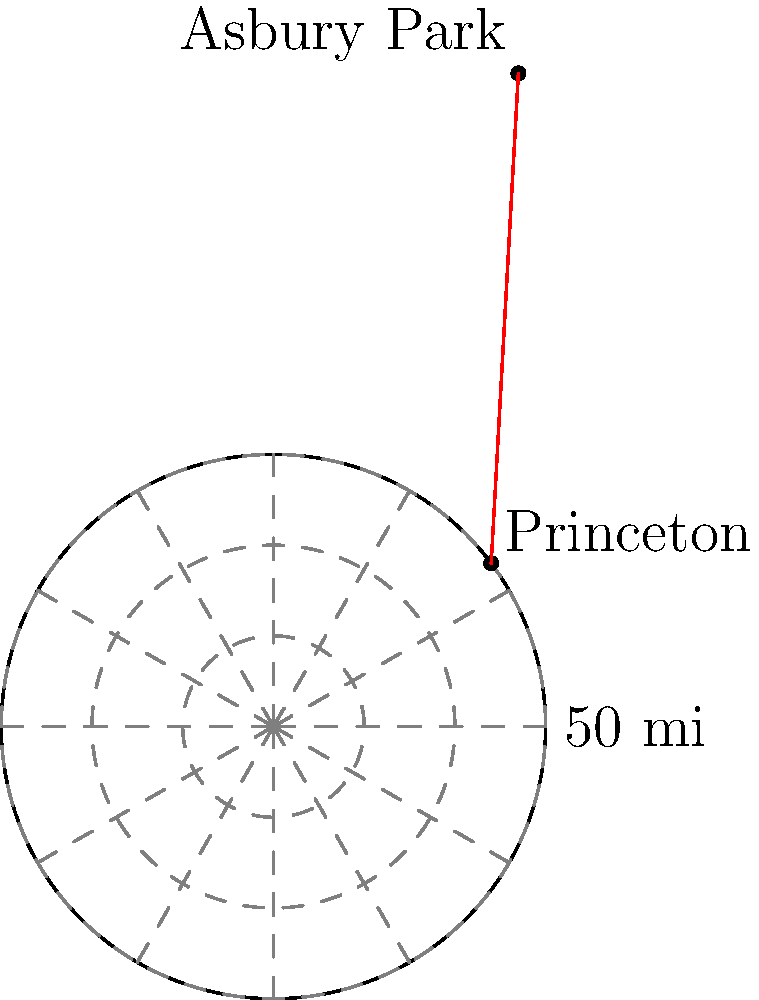As a proud member of the Central Jersey Club, you're planning a trip from Princeton to Asbury Park. On your polar coordinate map of New Jersey (with Princeton at the origin), Princeton is located at $(40, 30°)$ and Asbury Park is at $(45, 120°)$. Calculate the straight-line distance between these two landmarks in miles. To find the distance between two points in polar coordinates, we can use the polar form of the distance formula:

$$d = \sqrt{r_1^2 + r_2^2 - 2r_1r_2\cos(\theta_2 - \theta_1)}$$

Where:
- $r_1 = 40$ miles (Princeton's radius)
- $r_2 = 45$ miles (Asbury Park's radius)
- $\theta_1 = 30°$ (Princeton's angle)
- $\theta_2 = 120°$ (Asbury Park's angle)

Let's solve step by step:

1) First, calculate $\theta_2 - \theta_1$:
   $120° - 30° = 90°$

2) Now, let's plug all values into the formula:
   $$d = \sqrt{40^2 + 45^2 - 2(40)(45)\cos(90°)}$$

3) Simplify:
   $$d = \sqrt{1600 + 2025 - 3600\cos(90°)}$$

4) Recall that $\cos(90°) = 0$:
   $$d = \sqrt{1600 + 2025 - 0}$$

5) Add inside the square root:
   $$d = \sqrt{3625}$$

6) Calculate the square root:
   $$d ≈ 60.21 \text{ miles}$$

Therefore, the straight-line distance between Princeton and Asbury Park is approximately 60.21 miles.
Answer: 60.21 miles 